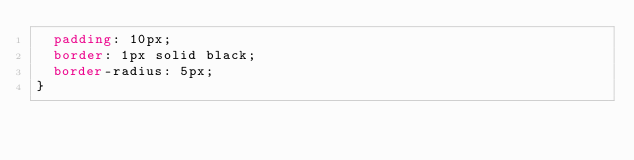Convert code to text. <code><loc_0><loc_0><loc_500><loc_500><_CSS_>	padding: 10px;
	border: 1px solid black;
	border-radius: 5px;
}
</code> 